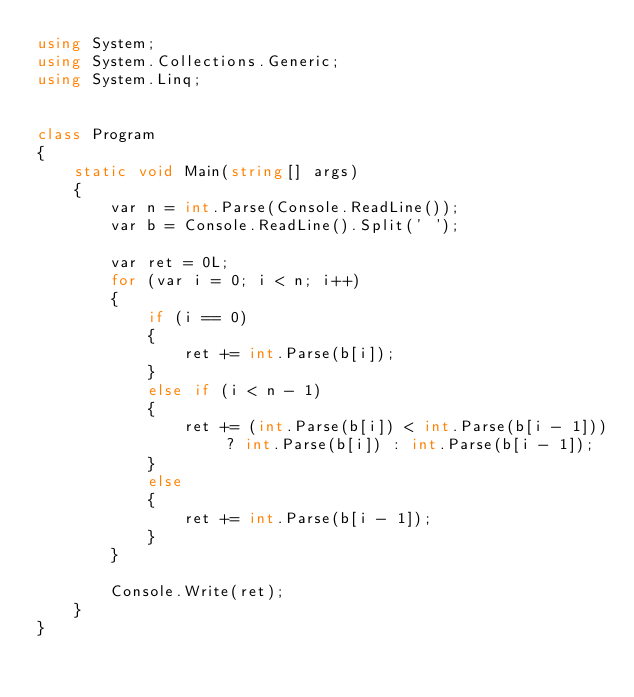<code> <loc_0><loc_0><loc_500><loc_500><_C#_>using System;
using System.Collections.Generic;
using System.Linq;


class Program
{
    static void Main(string[] args)
    {
        var n = int.Parse(Console.ReadLine());
        var b = Console.ReadLine().Split(' ');

        var ret = 0L;
        for (var i = 0; i < n; i++)
        {
            if (i == 0)
            {
                ret += int.Parse(b[i]);
            }
            else if (i < n - 1)
            {
                ret += (int.Parse(b[i]) < int.Parse(b[i - 1])) ? int.Parse(b[i]) : int.Parse(b[i - 1]);
            }
            else
            {
                ret += int.Parse(b[i - 1]);
            }
        }

        Console.Write(ret);
    }
}
</code> 